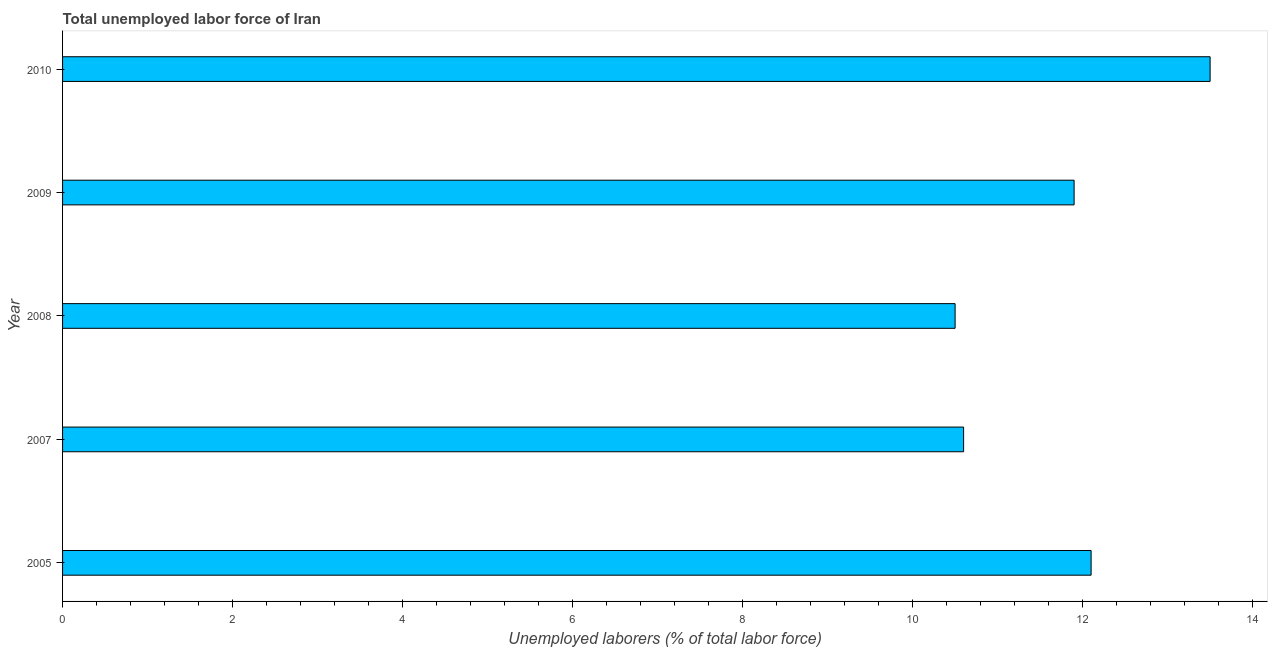What is the title of the graph?
Keep it short and to the point. Total unemployed labor force of Iran. What is the label or title of the X-axis?
Make the answer very short. Unemployed laborers (% of total labor force). What is the total unemployed labour force in 2007?
Keep it short and to the point. 10.6. Across all years, what is the maximum total unemployed labour force?
Give a very brief answer. 13.5. In which year was the total unemployed labour force minimum?
Give a very brief answer. 2008. What is the sum of the total unemployed labour force?
Provide a succinct answer. 58.6. What is the average total unemployed labour force per year?
Provide a succinct answer. 11.72. What is the median total unemployed labour force?
Your response must be concise. 11.9. In how many years, is the total unemployed labour force greater than 2.8 %?
Your response must be concise. 5. What is the ratio of the total unemployed labour force in 2008 to that in 2009?
Offer a terse response. 0.88. Is the total unemployed labour force in 2005 less than that in 2010?
Provide a short and direct response. Yes. Is the difference between the total unemployed labour force in 2005 and 2009 greater than the difference between any two years?
Your answer should be compact. No. What is the difference between the highest and the second highest total unemployed labour force?
Offer a very short reply. 1.4. What is the difference between the highest and the lowest total unemployed labour force?
Offer a terse response. 3. In how many years, is the total unemployed labour force greater than the average total unemployed labour force taken over all years?
Provide a short and direct response. 3. Are the values on the major ticks of X-axis written in scientific E-notation?
Give a very brief answer. No. What is the Unemployed laborers (% of total labor force) of 2005?
Your response must be concise. 12.1. What is the Unemployed laborers (% of total labor force) in 2007?
Your answer should be compact. 10.6. What is the Unemployed laborers (% of total labor force) in 2009?
Offer a terse response. 11.9. What is the difference between the Unemployed laborers (% of total labor force) in 2005 and 2008?
Provide a succinct answer. 1.6. What is the difference between the Unemployed laborers (% of total labor force) in 2005 and 2009?
Your answer should be very brief. 0.2. What is the difference between the Unemployed laborers (% of total labor force) in 2005 and 2010?
Ensure brevity in your answer.  -1.4. What is the difference between the Unemployed laborers (% of total labor force) in 2007 and 2008?
Keep it short and to the point. 0.1. What is the difference between the Unemployed laborers (% of total labor force) in 2007 and 2009?
Your answer should be very brief. -1.3. What is the difference between the Unemployed laborers (% of total labor force) in 2008 and 2010?
Offer a terse response. -3. What is the difference between the Unemployed laborers (% of total labor force) in 2009 and 2010?
Provide a succinct answer. -1.6. What is the ratio of the Unemployed laborers (% of total labor force) in 2005 to that in 2007?
Offer a terse response. 1.14. What is the ratio of the Unemployed laborers (% of total labor force) in 2005 to that in 2008?
Your answer should be compact. 1.15. What is the ratio of the Unemployed laborers (% of total labor force) in 2005 to that in 2009?
Make the answer very short. 1.02. What is the ratio of the Unemployed laborers (% of total labor force) in 2005 to that in 2010?
Provide a succinct answer. 0.9. What is the ratio of the Unemployed laborers (% of total labor force) in 2007 to that in 2009?
Ensure brevity in your answer.  0.89. What is the ratio of the Unemployed laborers (% of total labor force) in 2007 to that in 2010?
Provide a short and direct response. 0.79. What is the ratio of the Unemployed laborers (% of total labor force) in 2008 to that in 2009?
Make the answer very short. 0.88. What is the ratio of the Unemployed laborers (% of total labor force) in 2008 to that in 2010?
Offer a very short reply. 0.78. What is the ratio of the Unemployed laborers (% of total labor force) in 2009 to that in 2010?
Offer a terse response. 0.88. 